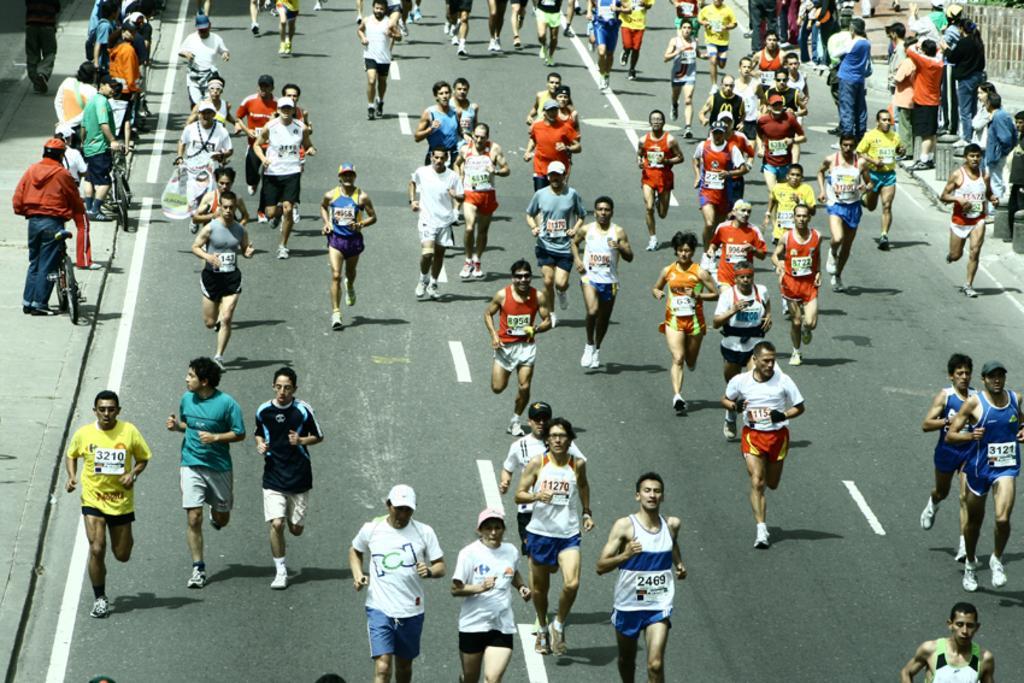Please provide a concise description of this image. In this image, there are people running on the road and in the background, there are some people standing with their bicycles. 